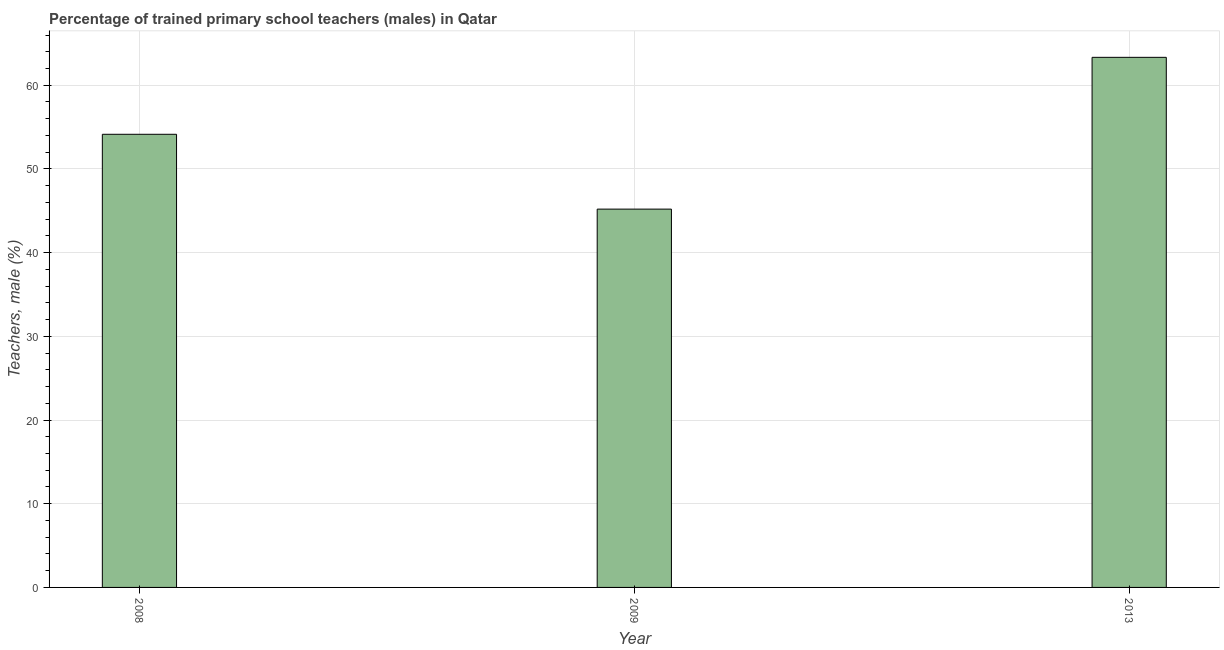Does the graph contain grids?
Keep it short and to the point. Yes. What is the title of the graph?
Give a very brief answer. Percentage of trained primary school teachers (males) in Qatar. What is the label or title of the X-axis?
Give a very brief answer. Year. What is the label or title of the Y-axis?
Make the answer very short. Teachers, male (%). What is the percentage of trained male teachers in 2013?
Provide a succinct answer. 63.33. Across all years, what is the maximum percentage of trained male teachers?
Make the answer very short. 63.33. Across all years, what is the minimum percentage of trained male teachers?
Your response must be concise. 45.2. What is the sum of the percentage of trained male teachers?
Offer a terse response. 162.67. What is the difference between the percentage of trained male teachers in 2008 and 2009?
Provide a short and direct response. 8.94. What is the average percentage of trained male teachers per year?
Offer a very short reply. 54.22. What is the median percentage of trained male teachers?
Your response must be concise. 54.14. What is the ratio of the percentage of trained male teachers in 2008 to that in 2013?
Your response must be concise. 0.85. Is the percentage of trained male teachers in 2008 less than that in 2013?
Ensure brevity in your answer.  Yes. Is the difference between the percentage of trained male teachers in 2009 and 2013 greater than the difference between any two years?
Keep it short and to the point. Yes. What is the difference between the highest and the second highest percentage of trained male teachers?
Keep it short and to the point. 9.2. Is the sum of the percentage of trained male teachers in 2008 and 2009 greater than the maximum percentage of trained male teachers across all years?
Provide a short and direct response. Yes. What is the difference between the highest and the lowest percentage of trained male teachers?
Offer a terse response. 18.14. Are the values on the major ticks of Y-axis written in scientific E-notation?
Your answer should be very brief. No. What is the Teachers, male (%) of 2008?
Make the answer very short. 54.14. What is the Teachers, male (%) of 2009?
Your answer should be compact. 45.2. What is the Teachers, male (%) of 2013?
Your answer should be very brief. 63.33. What is the difference between the Teachers, male (%) in 2008 and 2009?
Offer a very short reply. 8.94. What is the difference between the Teachers, male (%) in 2008 and 2013?
Provide a succinct answer. -9.2. What is the difference between the Teachers, male (%) in 2009 and 2013?
Give a very brief answer. -18.14. What is the ratio of the Teachers, male (%) in 2008 to that in 2009?
Your answer should be compact. 1.2. What is the ratio of the Teachers, male (%) in 2008 to that in 2013?
Your answer should be compact. 0.85. What is the ratio of the Teachers, male (%) in 2009 to that in 2013?
Provide a short and direct response. 0.71. 